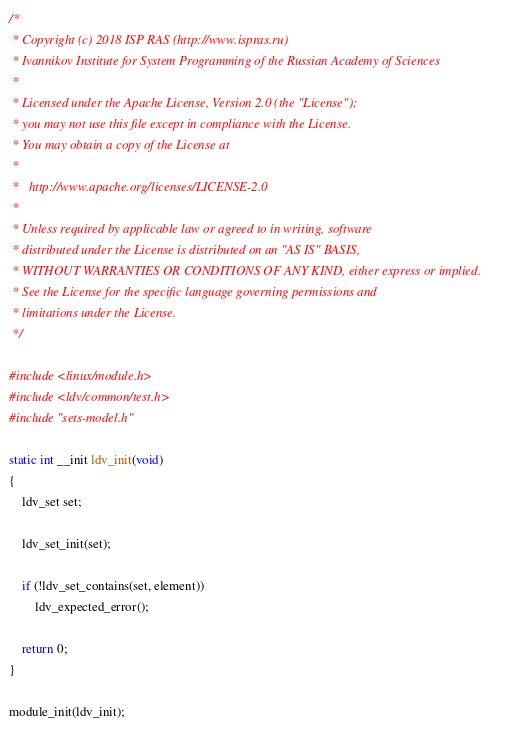Convert code to text. <code><loc_0><loc_0><loc_500><loc_500><_C_>/*
 * Copyright (c) 2018 ISP RAS (http://www.ispras.ru)
 * Ivannikov Institute for System Programming of the Russian Academy of Sciences
 *
 * Licensed under the Apache License, Version 2.0 (the "License");
 * you may not use this file except in compliance with the License.
 * You may obtain a copy of the License at
 *
 *   http://www.apache.org/licenses/LICENSE-2.0
 *
 * Unless required by applicable law or agreed to in writing, software
 * distributed under the License is distributed on an "AS IS" BASIS,
 * WITHOUT WARRANTIES OR CONDITIONS OF ANY KIND, either express or implied.
 * See the License for the specific language governing permissions and
 * limitations under the License.
 */

#include <linux/module.h>
#include <ldv/common/test.h>
#include "sets-model.h"

static int __init ldv_init(void)
{
	ldv_set set;

	ldv_set_init(set);

	if (!ldv_set_contains(set, element))
		ldv_expected_error();

	return 0;
}

module_init(ldv_init);
</code> 